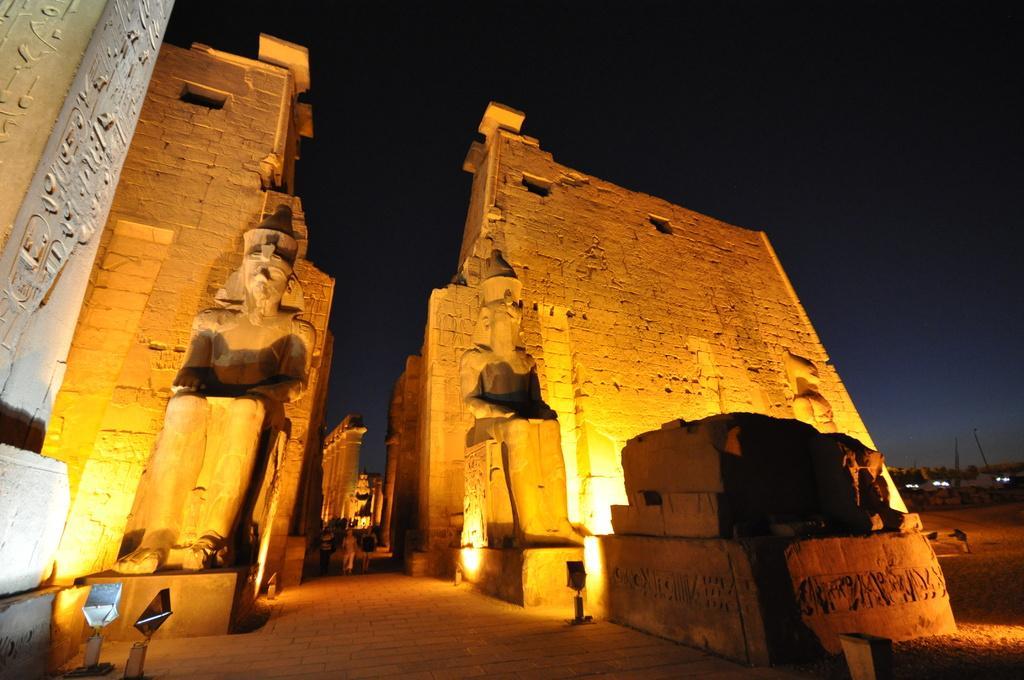Can you describe this image briefly? In this picture I can see the ancient monument and I can see the lights. In the middle of this picture I can see few people on the path. In the background I can see the sky which is dark. 